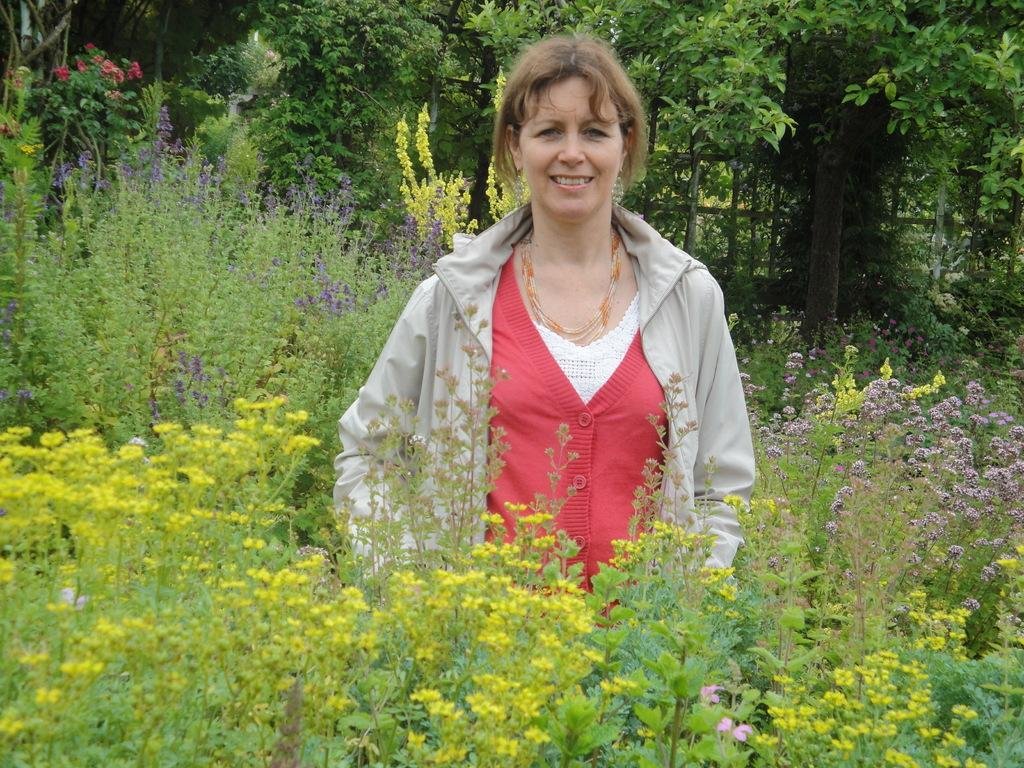What is the main subject in the image? There is a woman standing in the image. What type of vegetation can be seen in the image? There are plants, flowers, and trees in the image. What type of bone is visible in the image? There is no bone present in the image. How does the woman feel in the image? The image does not convey any specific feelings or emotions of the woman. 